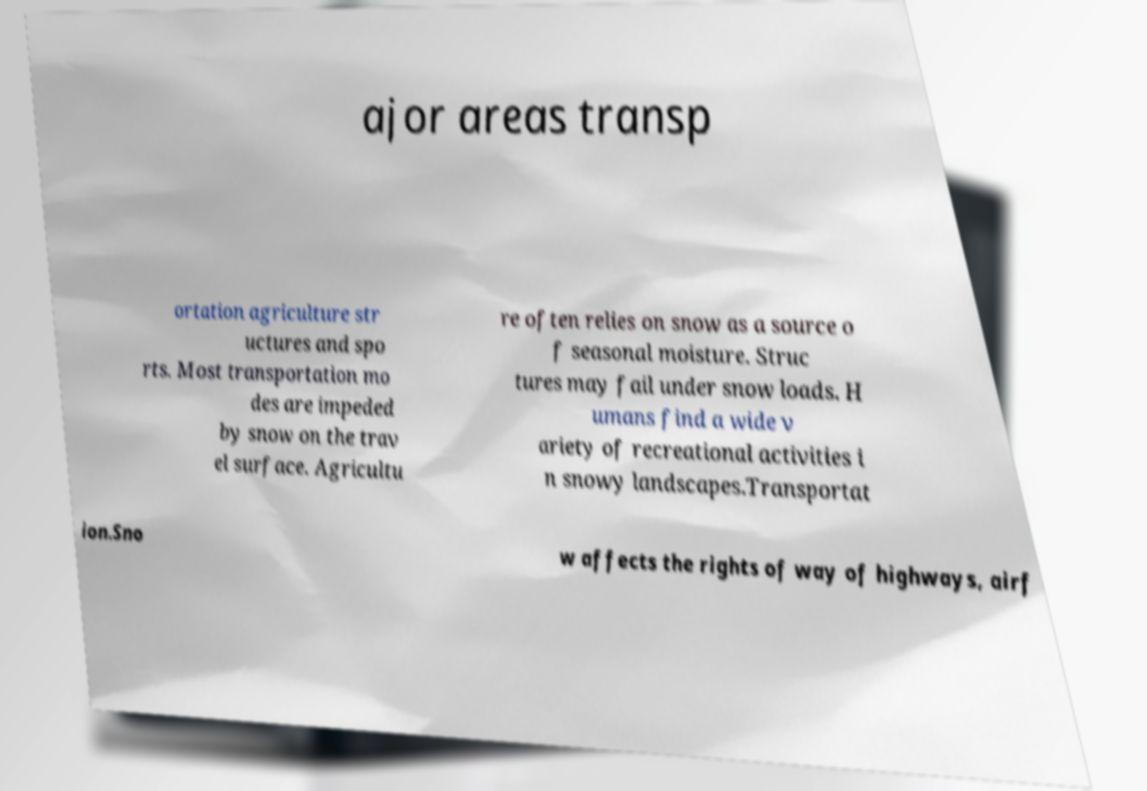For documentation purposes, I need the text within this image transcribed. Could you provide that? ajor areas transp ortation agriculture str uctures and spo rts. Most transportation mo des are impeded by snow on the trav el surface. Agricultu re often relies on snow as a source o f seasonal moisture. Struc tures may fail under snow loads. H umans find a wide v ariety of recreational activities i n snowy landscapes.Transportat ion.Sno w affects the rights of way of highways, airf 